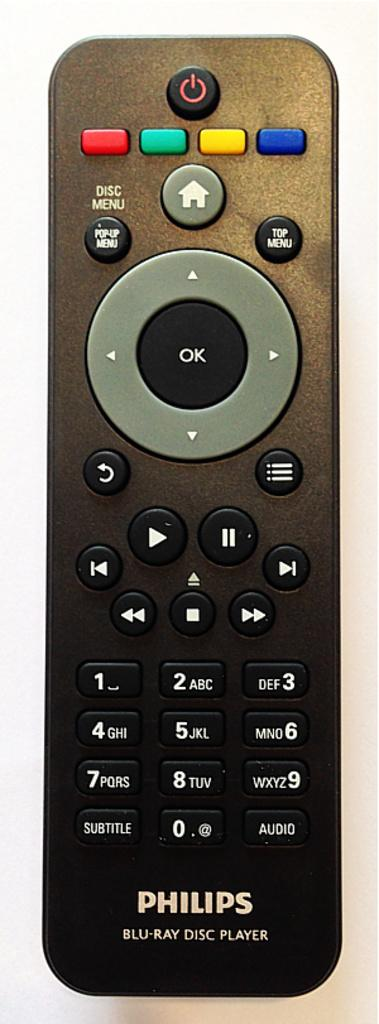<image>
Present a compact description of the photo's key features. A black Philips remote control on a white background 